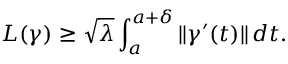<formula> <loc_0><loc_0><loc_500><loc_500>L ( \gamma ) \geq { \sqrt { \lambda } } \int _ { a } ^ { a + \delta } \| \gamma ^ { \prime } ( t ) \| \, d t .</formula> 